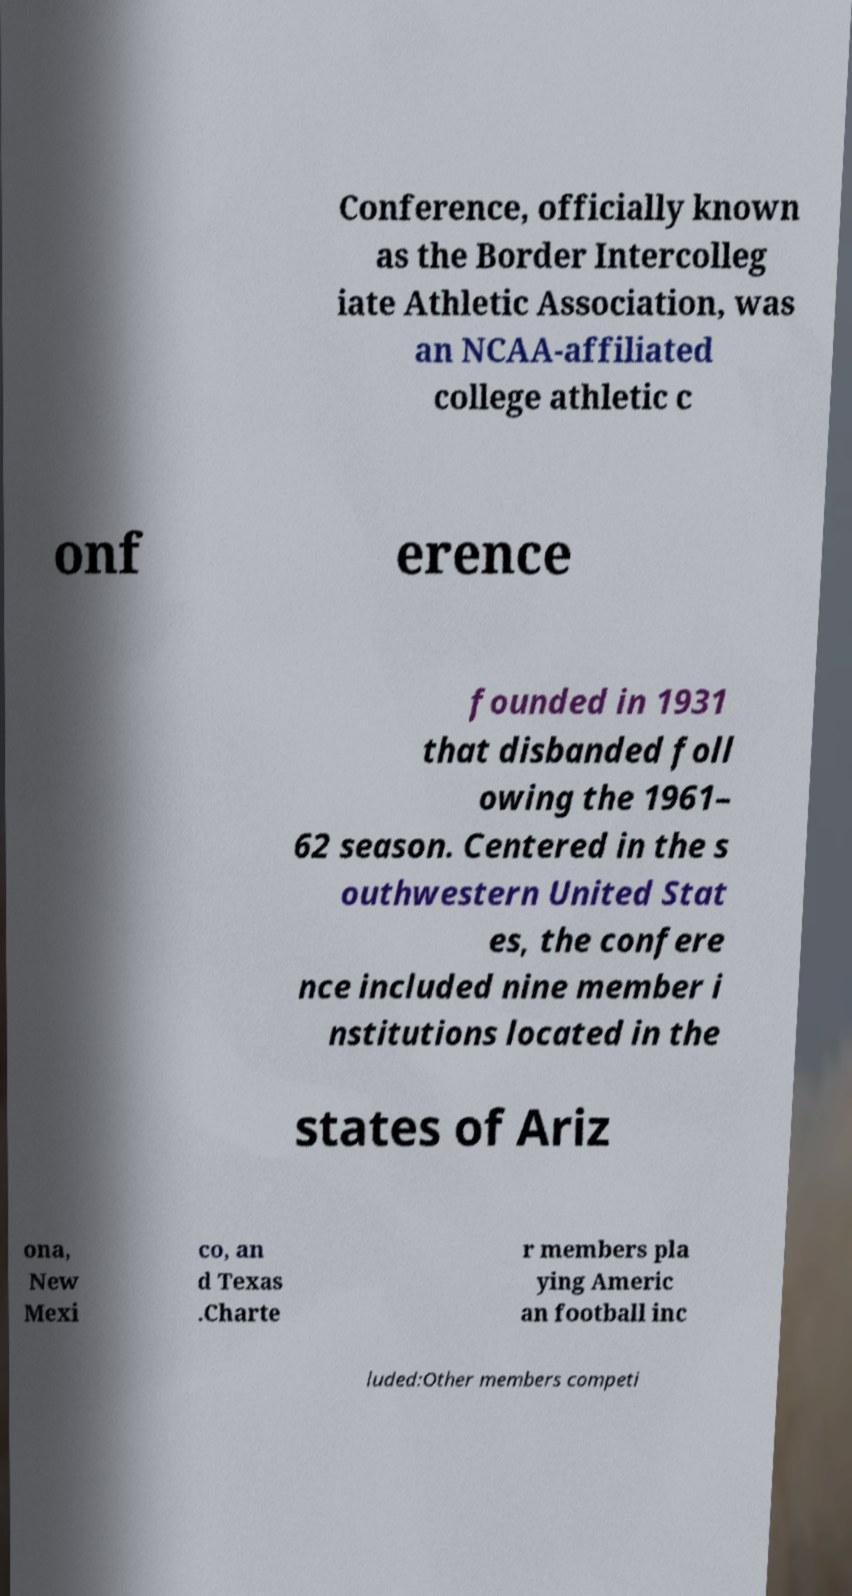For documentation purposes, I need the text within this image transcribed. Could you provide that? Conference, officially known as the Border Intercolleg iate Athletic Association, was an NCAA-affiliated college athletic c onf erence founded in 1931 that disbanded foll owing the 1961– 62 season. Centered in the s outhwestern United Stat es, the confere nce included nine member i nstitutions located in the states of Ariz ona, New Mexi co, an d Texas .Charte r members pla ying Americ an football inc luded:Other members competi 